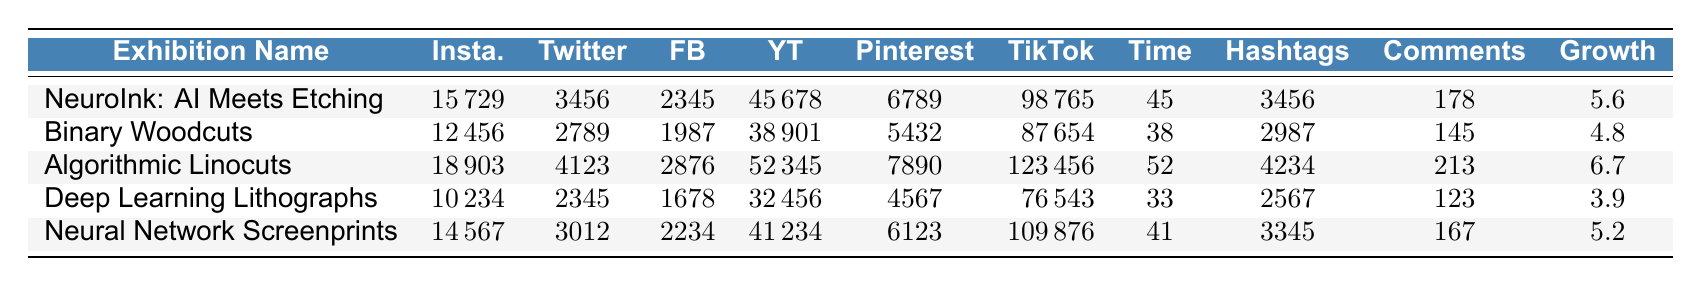What is the highest number of YouTube views among the exhibitions? The exhibition with the highest YouTube views is "Algorithmic Linocuts" with 52,345 views, as indicated in the table.
Answer: 52,345 Which exhibition had the lowest Instagram likes? The exhibition "Deep Learning Lithographs" has the lowest Instagram likes with a total of 10,234 likes.
Answer: 10,234 Calculate the average time spent on content across all exhibitions. The times spent are 45, 38, 52, 33, and 41 seconds. Their sum is 45 + 38 + 52 + 33 + 41 = 209 seconds. Divided by 5 exhibitions, the average is 209 / 5 = 41.8 seconds.
Answer: 41.8 Did "Binary Woodcuts" have more TikTok views than "Neural Network Screenprints"? "Binary Woodcuts" had 87,654 TikTok views, while "Neural Network Screenprints" had 109,876 views. Therefore, the statement is false, as "Binary Woodcuts" had fewer views.
Answer: No Which exhibition showed the highest follower growth percentage? "Algorithmic Linocuts" had the highest follower growth percentage with 6.7%, compared to the others, as seen in the growth column.
Answer: 6.7% What is the difference in comments per post between "NeuroInk: AI Meets Etching" and "Deep Learning Lithographs"? "NeuroInk: AI Meets Etching" received 178 comments per post, while "Deep Learning Lithographs" received 123 comments. The difference is 178 - 123 = 55 comments.
Answer: 55 Which social media platform received the most shares for the "NeuroInk: AI Meets Etching" exhibition? The highest number of shares for "NeuroInk: AI Meets Etching" was on Facebook, with a total of 2,345 shares, as detailed in the table.
Answer: 2,345 How many more TikTok views did "Algorithmic Linocuts" have compared to "Deep Learning Lithographs"? "Algorithmic Linocuts" had 123,456 TikTok views and "Deep Learning Lithographs" had 76,543 views. The difference is 123,456 - 76,543 = 46,913 views.
Answer: 46,913 Is the average Instagram likes higher or lower than 15,000? Adding the Instagram likes gives us 15,729 + 12,456 + 18,903 + 10,234 + 14,567 = 71,889 likes. Dividing by 5 gives an average of 14,377.8, which is lower than 15,000.
Answer: Lower Which exhibition had the most Pinterest saves? "Algorithmic Linocuts" had the most Pinterest saves with a total of 7,890 saves, according to the Pinterest saves data.
Answer: 7,890 